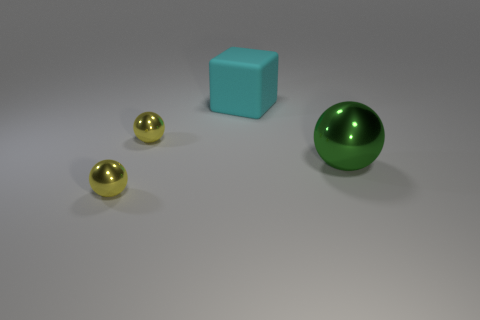If you had to guess, what materials might these objects be made of based on their appearance? Based on their appearance, the blue cube could be made of a rubber-like material due to its matte texture, while the spheres, especially the golden ones, could be metallic, owing to their reflective and shiny surfaces. The green sphere might be made of plastic or glass because of its translucency and glossy finish. 